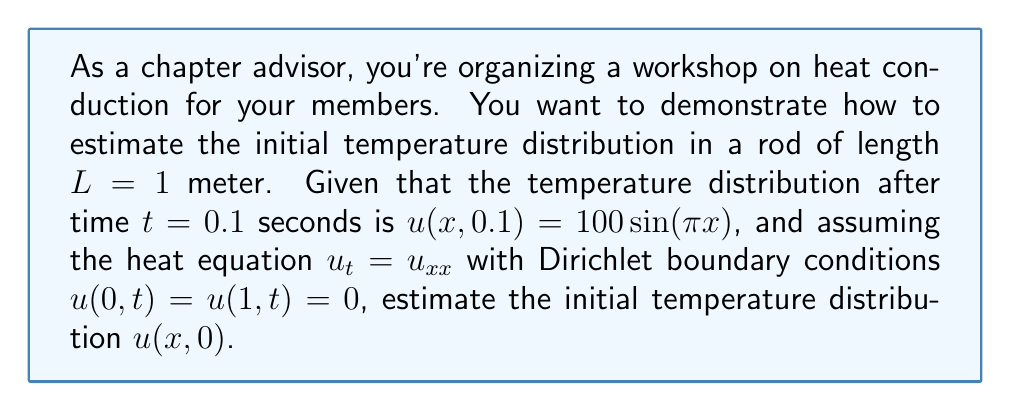Provide a solution to this math problem. Let's approach this step-by-step:

1) The general solution to the heat equation with Dirichlet boundary conditions is:

   $$u(x,t) = \sum_{n=1}^{\infty} b_n \sin(n\pi x) e^{-n^2\pi^2t}$$

2) We're given that at $t=0.1$, $u(x,0.1) = 100\sin(\pi x)$. This means that only the first term in the series is non-zero, and:

   $$100\sin(\pi x) = b_1 \sin(\pi x) e^{-\pi^2(0.1)}$$

3) Solving for $b_1$:

   $$b_1 = 100 e^{\pi^2(0.1)} \approx 100 e^{0.9869} \approx 268.34$$

4) Now, to find the initial distribution, we set $t=0$ in the general solution:

   $$u(x,0) = 268.34 \sin(\pi x)$$

5) This is our estimate of the initial temperature distribution.
Answer: $u(x,0) \approx 268.34 \sin(\pi x)$ 